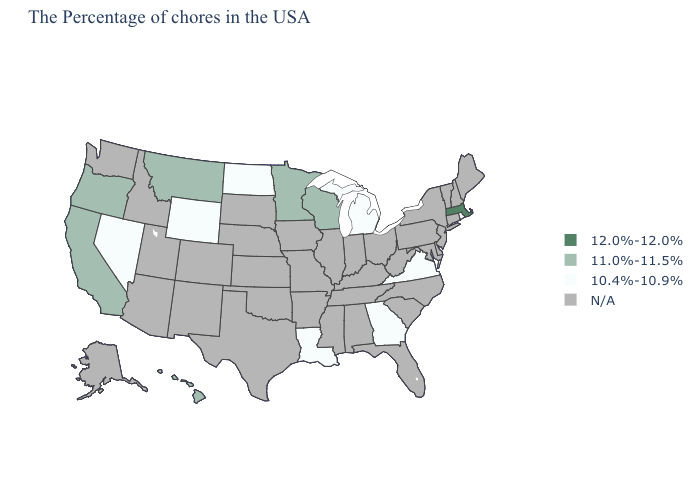Which states have the lowest value in the USA?
Give a very brief answer. Rhode Island, Virginia, Georgia, Michigan, Louisiana, North Dakota, Wyoming, Nevada. Name the states that have a value in the range 11.0%-11.5%?
Concise answer only. Wisconsin, Minnesota, Montana, California, Oregon, Hawaii. Among the states that border Wyoming , which have the lowest value?
Quick response, please. Montana. Name the states that have a value in the range N/A?
Keep it brief. Maine, New Hampshire, Vermont, Connecticut, New York, New Jersey, Delaware, Maryland, Pennsylvania, North Carolina, South Carolina, West Virginia, Ohio, Florida, Kentucky, Indiana, Alabama, Tennessee, Illinois, Mississippi, Missouri, Arkansas, Iowa, Kansas, Nebraska, Oklahoma, Texas, South Dakota, Colorado, New Mexico, Utah, Arizona, Idaho, Washington, Alaska. Name the states that have a value in the range 11.0%-11.5%?
Answer briefly. Wisconsin, Minnesota, Montana, California, Oregon, Hawaii. Name the states that have a value in the range 12.0%-12.0%?
Short answer required. Massachusetts. Which states hav the highest value in the MidWest?
Answer briefly. Wisconsin, Minnesota. Which states have the lowest value in the USA?
Keep it brief. Rhode Island, Virginia, Georgia, Michigan, Louisiana, North Dakota, Wyoming, Nevada. Name the states that have a value in the range N/A?
Answer briefly. Maine, New Hampshire, Vermont, Connecticut, New York, New Jersey, Delaware, Maryland, Pennsylvania, North Carolina, South Carolina, West Virginia, Ohio, Florida, Kentucky, Indiana, Alabama, Tennessee, Illinois, Mississippi, Missouri, Arkansas, Iowa, Kansas, Nebraska, Oklahoma, Texas, South Dakota, Colorado, New Mexico, Utah, Arizona, Idaho, Washington, Alaska. Name the states that have a value in the range 10.4%-10.9%?
Be succinct. Rhode Island, Virginia, Georgia, Michigan, Louisiana, North Dakota, Wyoming, Nevada. What is the value of Ohio?
Concise answer only. N/A. What is the value of Florida?
Be succinct. N/A. What is the lowest value in the MidWest?
Concise answer only. 10.4%-10.9%. What is the highest value in states that border West Virginia?
Short answer required. 10.4%-10.9%. 